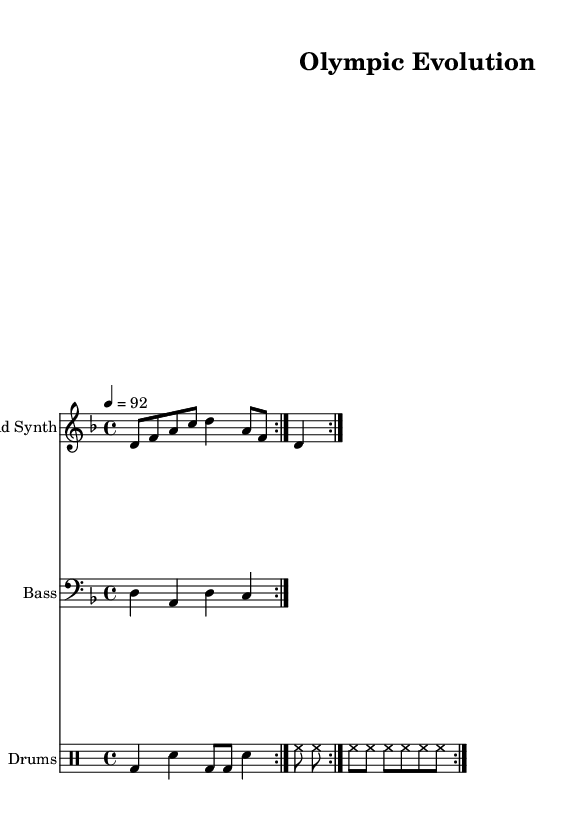What is the key signature of this music? The key signature is indicated at the beginning of the score and can be found near the clef. It shows one flat, which means it is D minor.
Answer: D minor What is the time signature of the piece? The time signature is shown at the start of the music, appearing as a fraction. It shows four beats per measure, which is represented as 4/4.
Answer: 4/4 What is the tempo marking of this piece? The tempo is indicated at the beginning, where it specifies the speed of the beat. It states that the tempo is 92 beats per minute.
Answer: 92 What style of music does this sheet represent? The title and lyrics, along with the instrumentation, suggest it is part of the rap genre, which is distinctive for its rhythmic vocal delivery.
Answer: Rap How many times is the lead synth part repeated in the score? The score has a notation for repetition, as indicated by the repeat symbol (volta) that shows the lead synth part is played twice.
Answer: 2 What is the theme of the lyrics in the verse? The lyrics express a journey from ancient Greece to the present day, highlighting the progression of Olympic sports over time.
Answer: Evolution What are the two instruments used in the score besides the drums? The score features the lead synth and the bass instruments as part of the ensemble alongside the drums.
Answer: Lead Synth and Bass 